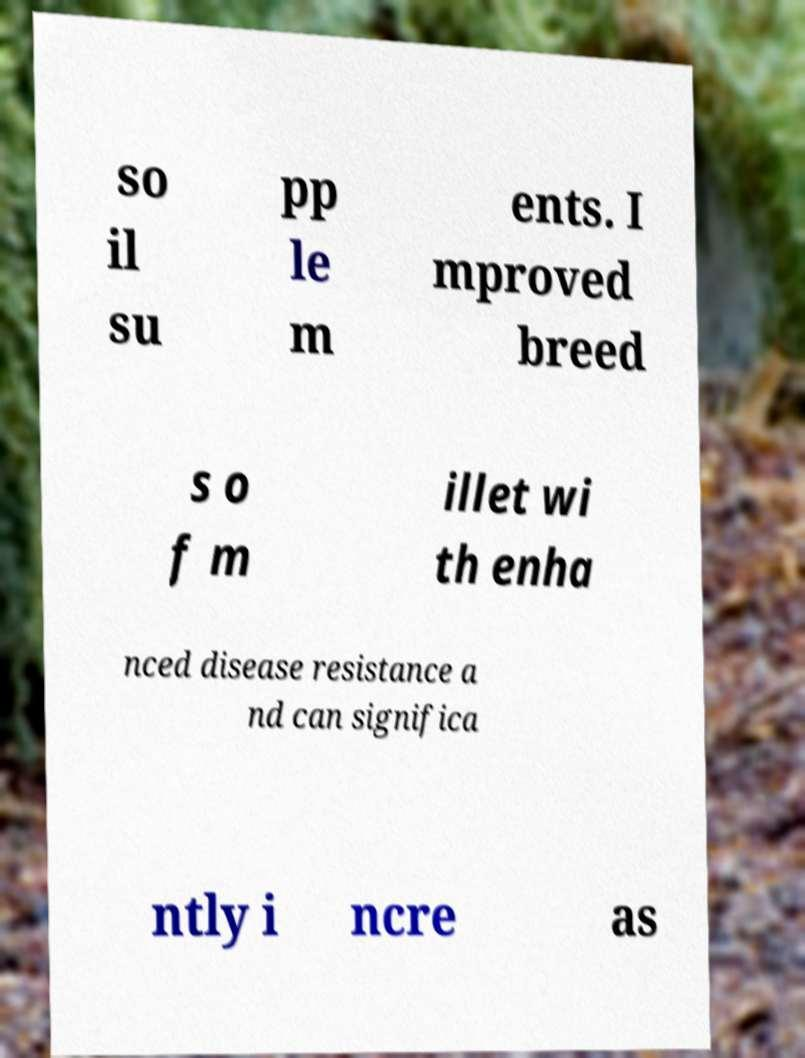Could you assist in decoding the text presented in this image and type it out clearly? so il su pp le m ents. I mproved breed s o f m illet wi th enha nced disease resistance a nd can significa ntly i ncre as 